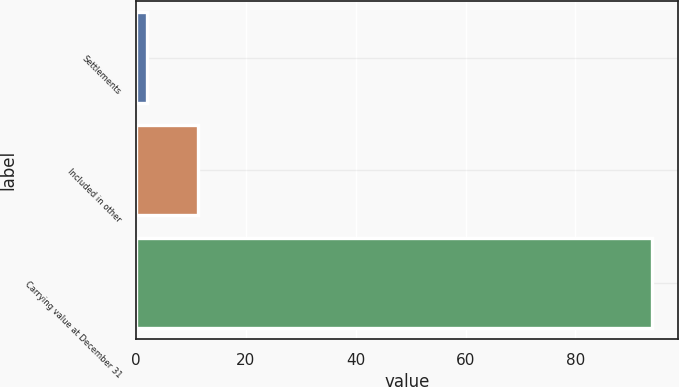Convert chart. <chart><loc_0><loc_0><loc_500><loc_500><bar_chart><fcel>Settlements<fcel>Included in other<fcel>Carrying value at December 31<nl><fcel>2<fcel>11.2<fcel>94<nl></chart> 